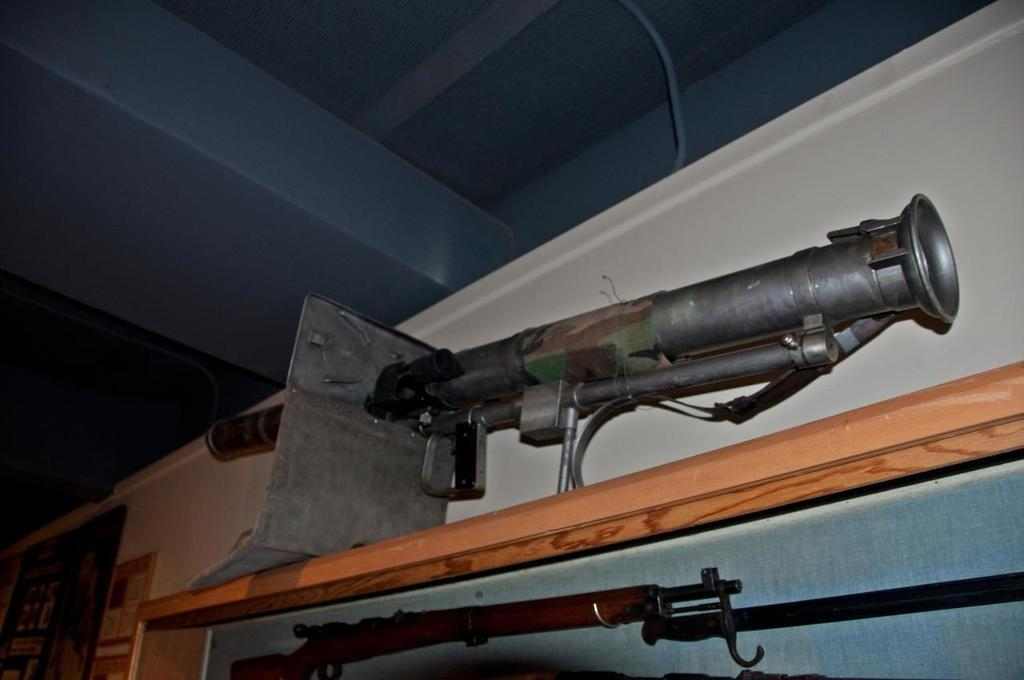What is the main object on the table in the image? There is a telescope on the table in the image. What is located at the bottom of the image? There is a gun at the bottom of the image. What can be seen attached to the wall in the background of the image? There are boards attached to the wall in the background of the image. What type of grape is being used as a comfort object in the image? There is no grape present in the image, and therefore no such comfort object can be observed. 